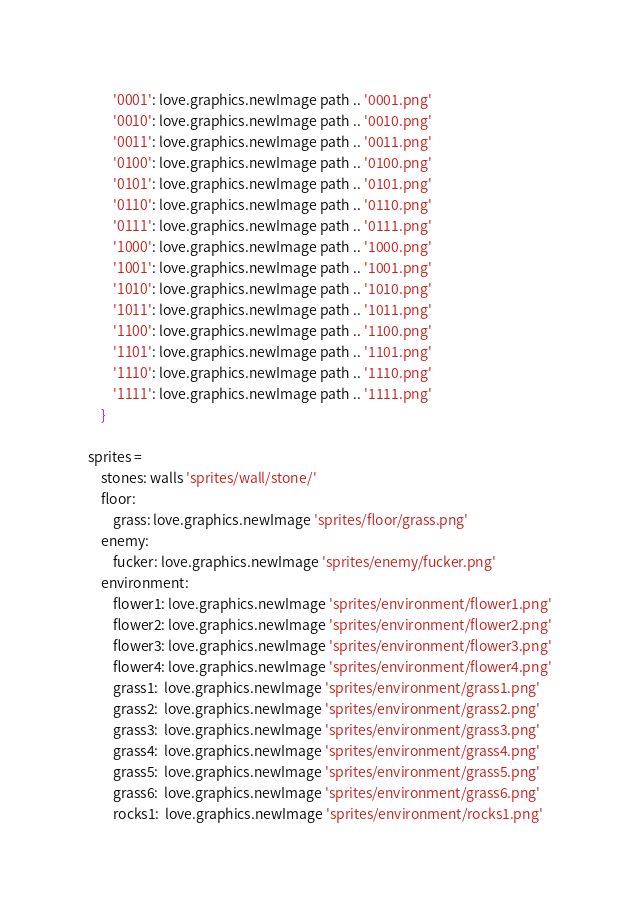<code> <loc_0><loc_0><loc_500><loc_500><_MoonScript_>        '0001': love.graphics.newImage path .. '0001.png'
        '0010': love.graphics.newImage path .. '0010.png'
        '0011': love.graphics.newImage path .. '0011.png'
        '0100': love.graphics.newImage path .. '0100.png'
        '0101': love.graphics.newImage path .. '0101.png'
        '0110': love.graphics.newImage path .. '0110.png'
        '0111': love.graphics.newImage path .. '0111.png'
        '1000': love.graphics.newImage path .. '1000.png'
        '1001': love.graphics.newImage path .. '1001.png'
        '1010': love.graphics.newImage path .. '1010.png'
        '1011': love.graphics.newImage path .. '1011.png'
        '1100': love.graphics.newImage path .. '1100.png'
        '1101': love.graphics.newImage path .. '1101.png'
        '1110': love.graphics.newImage path .. '1110.png'
        '1111': love.graphics.newImage path .. '1111.png'
    }

sprites =
    stones: walls 'sprites/wall/stone/'
    floor:
        grass: love.graphics.newImage 'sprites/floor/grass.png'
    enemy:
        fucker: love.graphics.newImage 'sprites/enemy/fucker.png'
    environment:
        flower1: love.graphics.newImage 'sprites/environment/flower1.png'
        flower2: love.graphics.newImage 'sprites/environment/flower2.png'
        flower3: love.graphics.newImage 'sprites/environment/flower3.png'
        flower4: love.graphics.newImage 'sprites/environment/flower4.png'
        grass1:  love.graphics.newImage 'sprites/environment/grass1.png'
        grass2:  love.graphics.newImage 'sprites/environment/grass2.png'
        grass3:  love.graphics.newImage 'sprites/environment/grass3.png'
        grass4:  love.graphics.newImage 'sprites/environment/grass4.png'
        grass5:  love.graphics.newImage 'sprites/environment/grass5.png'
        grass6:  love.graphics.newImage 'sprites/environment/grass6.png'
        rocks1:  love.graphics.newImage 'sprites/environment/rocks1.png'</code> 